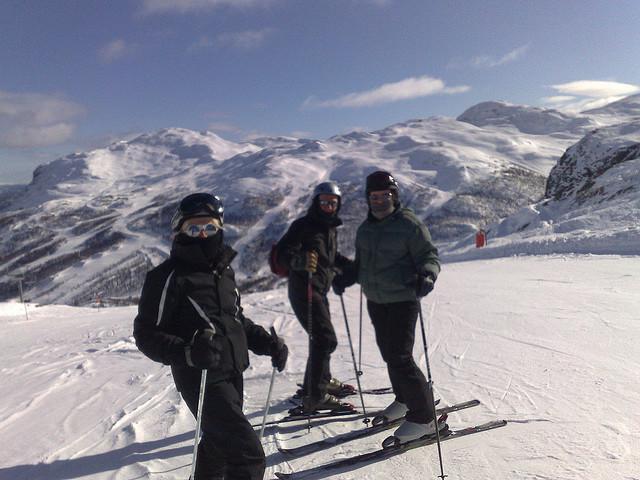How many skiers are there?
Give a very brief answer. 3. How many people are there?
Give a very brief answer. 3. 